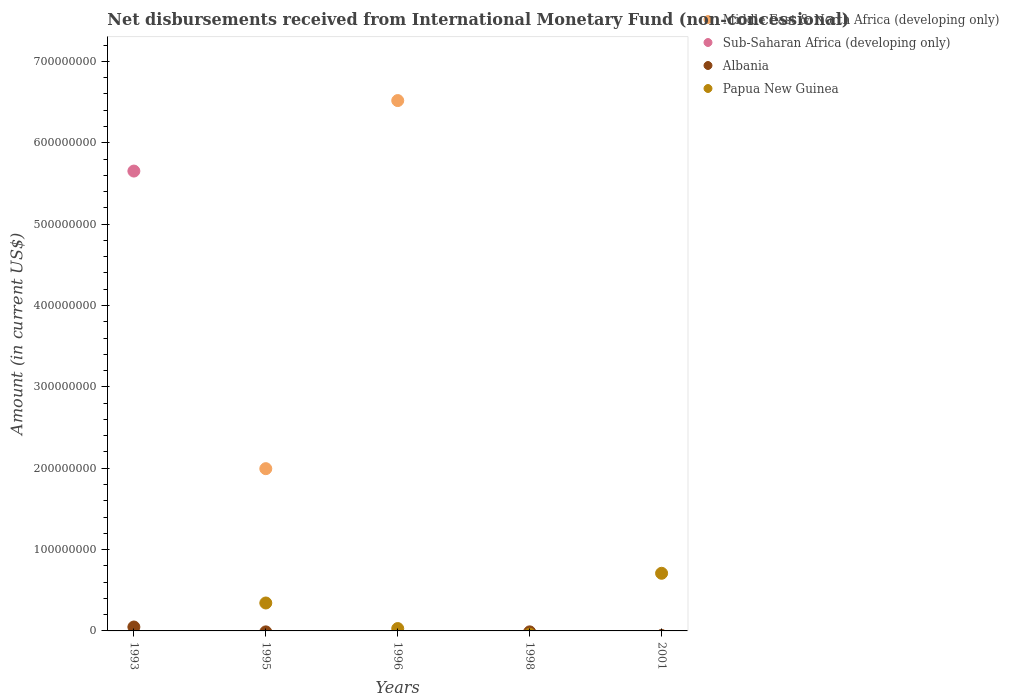What is the amount of disbursements received from International Monetary Fund in Papua New Guinea in 2001?
Ensure brevity in your answer.  7.09e+07. Across all years, what is the maximum amount of disbursements received from International Monetary Fund in Papua New Guinea?
Your answer should be compact. 7.09e+07. In which year was the amount of disbursements received from International Monetary Fund in Papua New Guinea maximum?
Provide a short and direct response. 2001. What is the total amount of disbursements received from International Monetary Fund in Middle East & North Africa (developing only) in the graph?
Provide a short and direct response. 8.51e+08. What is the difference between the amount of disbursements received from International Monetary Fund in Papua New Guinea in 1995 and that in 2001?
Ensure brevity in your answer.  -3.65e+07. What is the average amount of disbursements received from International Monetary Fund in Middle East & North Africa (developing only) per year?
Ensure brevity in your answer.  1.70e+08. What is the ratio of the amount of disbursements received from International Monetary Fund in Papua New Guinea in 1995 to that in 1996?
Your answer should be very brief. 11.82. What is the difference between the highest and the second highest amount of disbursements received from International Monetary Fund in Papua New Guinea?
Ensure brevity in your answer.  3.65e+07. What is the difference between the highest and the lowest amount of disbursements received from International Monetary Fund in Albania?
Your answer should be compact. 4.80e+06. In how many years, is the amount of disbursements received from International Monetary Fund in Albania greater than the average amount of disbursements received from International Monetary Fund in Albania taken over all years?
Provide a short and direct response. 1. Is the sum of the amount of disbursements received from International Monetary Fund in Papua New Guinea in 1995 and 2001 greater than the maximum amount of disbursements received from International Monetary Fund in Albania across all years?
Your answer should be compact. Yes. Is it the case that in every year, the sum of the amount of disbursements received from International Monetary Fund in Papua New Guinea and amount of disbursements received from International Monetary Fund in Albania  is greater than the amount of disbursements received from International Monetary Fund in Sub-Saharan Africa (developing only)?
Ensure brevity in your answer.  No. How many dotlines are there?
Offer a very short reply. 4. What is the difference between two consecutive major ticks on the Y-axis?
Your answer should be very brief. 1.00e+08. Does the graph contain any zero values?
Provide a succinct answer. Yes. Where does the legend appear in the graph?
Give a very brief answer. Top right. How many legend labels are there?
Provide a short and direct response. 4. How are the legend labels stacked?
Your answer should be compact. Vertical. What is the title of the graph?
Provide a succinct answer. Net disbursements received from International Monetary Fund (non-concessional). Does "Low & middle income" appear as one of the legend labels in the graph?
Make the answer very short. No. What is the label or title of the Y-axis?
Provide a short and direct response. Amount (in current US$). What is the Amount (in current US$) of Sub-Saharan Africa (developing only) in 1993?
Make the answer very short. 5.65e+08. What is the Amount (in current US$) in Albania in 1993?
Keep it short and to the point. 4.80e+06. What is the Amount (in current US$) of Middle East & North Africa (developing only) in 1995?
Your response must be concise. 1.99e+08. What is the Amount (in current US$) of Sub-Saharan Africa (developing only) in 1995?
Your answer should be compact. 0. What is the Amount (in current US$) in Papua New Guinea in 1995?
Offer a very short reply. 3.43e+07. What is the Amount (in current US$) in Middle East & North Africa (developing only) in 1996?
Your response must be concise. 6.52e+08. What is the Amount (in current US$) in Sub-Saharan Africa (developing only) in 1996?
Your answer should be compact. 0. What is the Amount (in current US$) in Papua New Guinea in 1996?
Give a very brief answer. 2.90e+06. What is the Amount (in current US$) of Albania in 1998?
Provide a short and direct response. 0. What is the Amount (in current US$) in Papua New Guinea in 1998?
Make the answer very short. 0. What is the Amount (in current US$) of Middle East & North Africa (developing only) in 2001?
Provide a short and direct response. 0. What is the Amount (in current US$) of Sub-Saharan Africa (developing only) in 2001?
Offer a terse response. 0. What is the Amount (in current US$) of Albania in 2001?
Make the answer very short. 0. What is the Amount (in current US$) in Papua New Guinea in 2001?
Make the answer very short. 7.09e+07. Across all years, what is the maximum Amount (in current US$) of Middle East & North Africa (developing only)?
Offer a terse response. 6.52e+08. Across all years, what is the maximum Amount (in current US$) in Sub-Saharan Africa (developing only)?
Your answer should be compact. 5.65e+08. Across all years, what is the maximum Amount (in current US$) in Albania?
Your answer should be compact. 4.80e+06. Across all years, what is the maximum Amount (in current US$) of Papua New Guinea?
Your response must be concise. 7.09e+07. Across all years, what is the minimum Amount (in current US$) of Sub-Saharan Africa (developing only)?
Your answer should be compact. 0. Across all years, what is the minimum Amount (in current US$) of Albania?
Make the answer very short. 0. What is the total Amount (in current US$) of Middle East & North Africa (developing only) in the graph?
Keep it short and to the point. 8.51e+08. What is the total Amount (in current US$) in Sub-Saharan Africa (developing only) in the graph?
Give a very brief answer. 5.65e+08. What is the total Amount (in current US$) of Albania in the graph?
Make the answer very short. 4.80e+06. What is the total Amount (in current US$) in Papua New Guinea in the graph?
Offer a very short reply. 1.08e+08. What is the difference between the Amount (in current US$) of Middle East & North Africa (developing only) in 1995 and that in 1996?
Your response must be concise. -4.52e+08. What is the difference between the Amount (in current US$) in Papua New Guinea in 1995 and that in 1996?
Your response must be concise. 3.14e+07. What is the difference between the Amount (in current US$) of Papua New Guinea in 1995 and that in 2001?
Provide a succinct answer. -3.65e+07. What is the difference between the Amount (in current US$) in Papua New Guinea in 1996 and that in 2001?
Offer a very short reply. -6.80e+07. What is the difference between the Amount (in current US$) in Sub-Saharan Africa (developing only) in 1993 and the Amount (in current US$) in Papua New Guinea in 1995?
Provide a short and direct response. 5.31e+08. What is the difference between the Amount (in current US$) in Albania in 1993 and the Amount (in current US$) in Papua New Guinea in 1995?
Your answer should be compact. -2.95e+07. What is the difference between the Amount (in current US$) in Sub-Saharan Africa (developing only) in 1993 and the Amount (in current US$) in Papua New Guinea in 1996?
Your response must be concise. 5.62e+08. What is the difference between the Amount (in current US$) in Albania in 1993 and the Amount (in current US$) in Papua New Guinea in 1996?
Keep it short and to the point. 1.90e+06. What is the difference between the Amount (in current US$) in Sub-Saharan Africa (developing only) in 1993 and the Amount (in current US$) in Papua New Guinea in 2001?
Provide a succinct answer. 4.94e+08. What is the difference between the Amount (in current US$) of Albania in 1993 and the Amount (in current US$) of Papua New Guinea in 2001?
Make the answer very short. -6.61e+07. What is the difference between the Amount (in current US$) in Middle East & North Africa (developing only) in 1995 and the Amount (in current US$) in Papua New Guinea in 1996?
Your answer should be compact. 1.97e+08. What is the difference between the Amount (in current US$) of Middle East & North Africa (developing only) in 1995 and the Amount (in current US$) of Papua New Guinea in 2001?
Provide a short and direct response. 1.29e+08. What is the difference between the Amount (in current US$) of Middle East & North Africa (developing only) in 1996 and the Amount (in current US$) of Papua New Guinea in 2001?
Provide a succinct answer. 5.81e+08. What is the average Amount (in current US$) in Middle East & North Africa (developing only) per year?
Your response must be concise. 1.70e+08. What is the average Amount (in current US$) of Sub-Saharan Africa (developing only) per year?
Your answer should be compact. 1.13e+08. What is the average Amount (in current US$) in Albania per year?
Provide a short and direct response. 9.60e+05. What is the average Amount (in current US$) in Papua New Guinea per year?
Your response must be concise. 2.16e+07. In the year 1993, what is the difference between the Amount (in current US$) of Sub-Saharan Africa (developing only) and Amount (in current US$) of Albania?
Your answer should be compact. 5.60e+08. In the year 1995, what is the difference between the Amount (in current US$) in Middle East & North Africa (developing only) and Amount (in current US$) in Papua New Guinea?
Offer a terse response. 1.65e+08. In the year 1996, what is the difference between the Amount (in current US$) in Middle East & North Africa (developing only) and Amount (in current US$) in Papua New Guinea?
Make the answer very short. 6.49e+08. What is the ratio of the Amount (in current US$) of Middle East & North Africa (developing only) in 1995 to that in 1996?
Provide a succinct answer. 0.31. What is the ratio of the Amount (in current US$) in Papua New Guinea in 1995 to that in 1996?
Your answer should be compact. 11.82. What is the ratio of the Amount (in current US$) of Papua New Guinea in 1995 to that in 2001?
Keep it short and to the point. 0.48. What is the ratio of the Amount (in current US$) in Papua New Guinea in 1996 to that in 2001?
Provide a short and direct response. 0.04. What is the difference between the highest and the second highest Amount (in current US$) in Papua New Guinea?
Your answer should be compact. 3.65e+07. What is the difference between the highest and the lowest Amount (in current US$) in Middle East & North Africa (developing only)?
Provide a succinct answer. 6.52e+08. What is the difference between the highest and the lowest Amount (in current US$) of Sub-Saharan Africa (developing only)?
Provide a succinct answer. 5.65e+08. What is the difference between the highest and the lowest Amount (in current US$) of Albania?
Give a very brief answer. 4.80e+06. What is the difference between the highest and the lowest Amount (in current US$) of Papua New Guinea?
Your answer should be compact. 7.09e+07. 